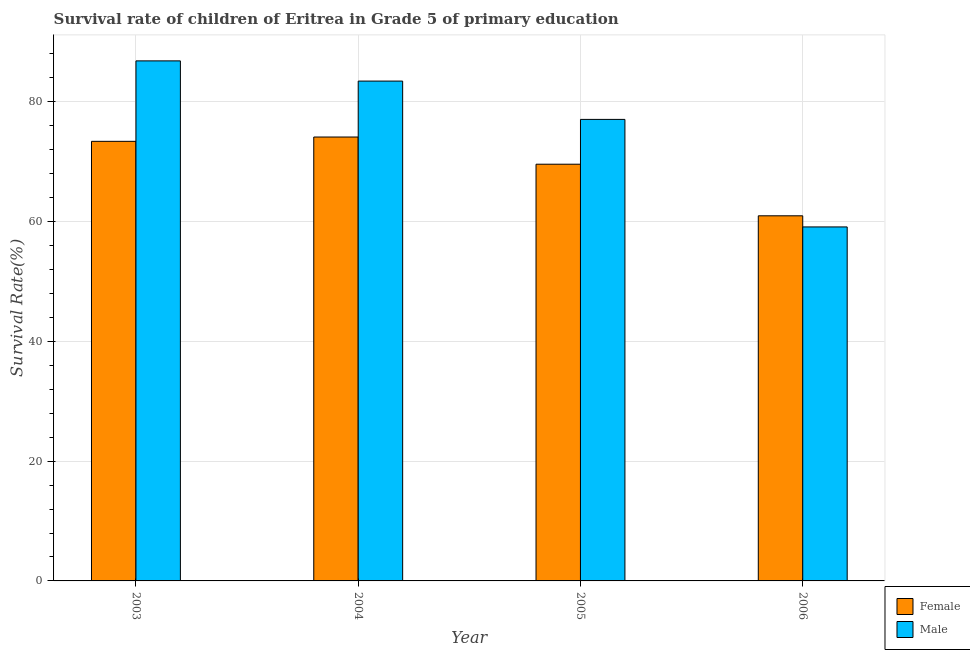How many groups of bars are there?
Your answer should be compact. 4. Are the number of bars per tick equal to the number of legend labels?
Your response must be concise. Yes. Are the number of bars on each tick of the X-axis equal?
Give a very brief answer. Yes. How many bars are there on the 2nd tick from the left?
Ensure brevity in your answer.  2. What is the label of the 2nd group of bars from the left?
Your answer should be compact. 2004. What is the survival rate of female students in primary education in 2004?
Your response must be concise. 74.13. Across all years, what is the maximum survival rate of female students in primary education?
Offer a terse response. 74.13. Across all years, what is the minimum survival rate of male students in primary education?
Provide a short and direct response. 59.12. In which year was the survival rate of male students in primary education maximum?
Provide a succinct answer. 2003. In which year was the survival rate of male students in primary education minimum?
Give a very brief answer. 2006. What is the total survival rate of male students in primary education in the graph?
Your answer should be compact. 306.52. What is the difference between the survival rate of male students in primary education in 2004 and that in 2006?
Keep it short and to the point. 24.36. What is the difference between the survival rate of male students in primary education in 2005 and the survival rate of female students in primary education in 2003?
Your answer should be compact. -9.77. What is the average survival rate of male students in primary education per year?
Provide a short and direct response. 76.63. What is the ratio of the survival rate of female students in primary education in 2003 to that in 2005?
Give a very brief answer. 1.05. Is the survival rate of male students in primary education in 2005 less than that in 2006?
Make the answer very short. No. What is the difference between the highest and the second highest survival rate of male students in primary education?
Your answer should be compact. 3.37. What is the difference between the highest and the lowest survival rate of male students in primary education?
Offer a terse response. 27.73. In how many years, is the survival rate of female students in primary education greater than the average survival rate of female students in primary education taken over all years?
Provide a short and direct response. 3. Is the sum of the survival rate of male students in primary education in 2003 and 2005 greater than the maximum survival rate of female students in primary education across all years?
Give a very brief answer. Yes. How many years are there in the graph?
Provide a short and direct response. 4. Does the graph contain any zero values?
Give a very brief answer. No. Does the graph contain grids?
Your answer should be compact. Yes. What is the title of the graph?
Make the answer very short. Survival rate of children of Eritrea in Grade 5 of primary education. Does "Lowest 20% of population" appear as one of the legend labels in the graph?
Your answer should be compact. No. What is the label or title of the X-axis?
Make the answer very short. Year. What is the label or title of the Y-axis?
Your response must be concise. Survival Rate(%). What is the Survival Rate(%) of Female in 2003?
Offer a very short reply. 73.41. What is the Survival Rate(%) in Male in 2003?
Keep it short and to the point. 86.85. What is the Survival Rate(%) of Female in 2004?
Your answer should be very brief. 74.13. What is the Survival Rate(%) of Male in 2004?
Ensure brevity in your answer.  83.48. What is the Survival Rate(%) of Female in 2005?
Provide a succinct answer. 69.59. What is the Survival Rate(%) in Male in 2005?
Offer a very short reply. 77.08. What is the Survival Rate(%) in Female in 2006?
Ensure brevity in your answer.  60.98. What is the Survival Rate(%) in Male in 2006?
Ensure brevity in your answer.  59.12. Across all years, what is the maximum Survival Rate(%) of Female?
Ensure brevity in your answer.  74.13. Across all years, what is the maximum Survival Rate(%) of Male?
Your response must be concise. 86.85. Across all years, what is the minimum Survival Rate(%) of Female?
Make the answer very short. 60.98. Across all years, what is the minimum Survival Rate(%) in Male?
Offer a terse response. 59.12. What is the total Survival Rate(%) of Female in the graph?
Provide a succinct answer. 278.12. What is the total Survival Rate(%) in Male in the graph?
Your answer should be compact. 306.52. What is the difference between the Survival Rate(%) in Female in 2003 and that in 2004?
Offer a very short reply. -0.72. What is the difference between the Survival Rate(%) of Male in 2003 and that in 2004?
Provide a short and direct response. 3.37. What is the difference between the Survival Rate(%) in Female in 2003 and that in 2005?
Your response must be concise. 3.82. What is the difference between the Survival Rate(%) of Male in 2003 and that in 2005?
Your response must be concise. 9.77. What is the difference between the Survival Rate(%) of Female in 2003 and that in 2006?
Make the answer very short. 12.44. What is the difference between the Survival Rate(%) of Male in 2003 and that in 2006?
Your answer should be compact. 27.73. What is the difference between the Survival Rate(%) in Female in 2004 and that in 2005?
Keep it short and to the point. 4.54. What is the difference between the Survival Rate(%) of Male in 2004 and that in 2005?
Your answer should be very brief. 6.4. What is the difference between the Survival Rate(%) in Female in 2004 and that in 2006?
Provide a short and direct response. 13.16. What is the difference between the Survival Rate(%) in Male in 2004 and that in 2006?
Make the answer very short. 24.36. What is the difference between the Survival Rate(%) of Female in 2005 and that in 2006?
Make the answer very short. 8.62. What is the difference between the Survival Rate(%) in Male in 2005 and that in 2006?
Offer a very short reply. 17.96. What is the difference between the Survival Rate(%) in Female in 2003 and the Survival Rate(%) in Male in 2004?
Your response must be concise. -10.06. What is the difference between the Survival Rate(%) of Female in 2003 and the Survival Rate(%) of Male in 2005?
Ensure brevity in your answer.  -3.66. What is the difference between the Survival Rate(%) of Female in 2003 and the Survival Rate(%) of Male in 2006?
Keep it short and to the point. 14.29. What is the difference between the Survival Rate(%) in Female in 2004 and the Survival Rate(%) in Male in 2005?
Keep it short and to the point. -2.94. What is the difference between the Survival Rate(%) of Female in 2004 and the Survival Rate(%) of Male in 2006?
Offer a very short reply. 15.02. What is the difference between the Survival Rate(%) of Female in 2005 and the Survival Rate(%) of Male in 2006?
Offer a very short reply. 10.47. What is the average Survival Rate(%) in Female per year?
Ensure brevity in your answer.  69.53. What is the average Survival Rate(%) in Male per year?
Keep it short and to the point. 76.63. In the year 2003, what is the difference between the Survival Rate(%) of Female and Survival Rate(%) of Male?
Your answer should be very brief. -13.44. In the year 2004, what is the difference between the Survival Rate(%) in Female and Survival Rate(%) in Male?
Ensure brevity in your answer.  -9.34. In the year 2005, what is the difference between the Survival Rate(%) of Female and Survival Rate(%) of Male?
Your answer should be compact. -7.48. In the year 2006, what is the difference between the Survival Rate(%) in Female and Survival Rate(%) in Male?
Provide a short and direct response. 1.86. What is the ratio of the Survival Rate(%) of Female in 2003 to that in 2004?
Keep it short and to the point. 0.99. What is the ratio of the Survival Rate(%) in Male in 2003 to that in 2004?
Ensure brevity in your answer.  1.04. What is the ratio of the Survival Rate(%) in Female in 2003 to that in 2005?
Offer a terse response. 1.05. What is the ratio of the Survival Rate(%) in Male in 2003 to that in 2005?
Offer a terse response. 1.13. What is the ratio of the Survival Rate(%) in Female in 2003 to that in 2006?
Your answer should be compact. 1.2. What is the ratio of the Survival Rate(%) of Male in 2003 to that in 2006?
Offer a very short reply. 1.47. What is the ratio of the Survival Rate(%) in Female in 2004 to that in 2005?
Your response must be concise. 1.07. What is the ratio of the Survival Rate(%) in Male in 2004 to that in 2005?
Your response must be concise. 1.08. What is the ratio of the Survival Rate(%) of Female in 2004 to that in 2006?
Offer a very short reply. 1.22. What is the ratio of the Survival Rate(%) in Male in 2004 to that in 2006?
Provide a succinct answer. 1.41. What is the ratio of the Survival Rate(%) of Female in 2005 to that in 2006?
Offer a terse response. 1.14. What is the ratio of the Survival Rate(%) of Male in 2005 to that in 2006?
Your response must be concise. 1.3. What is the difference between the highest and the second highest Survival Rate(%) of Female?
Your answer should be compact. 0.72. What is the difference between the highest and the second highest Survival Rate(%) of Male?
Provide a short and direct response. 3.37. What is the difference between the highest and the lowest Survival Rate(%) in Female?
Your answer should be compact. 13.16. What is the difference between the highest and the lowest Survival Rate(%) of Male?
Provide a short and direct response. 27.73. 